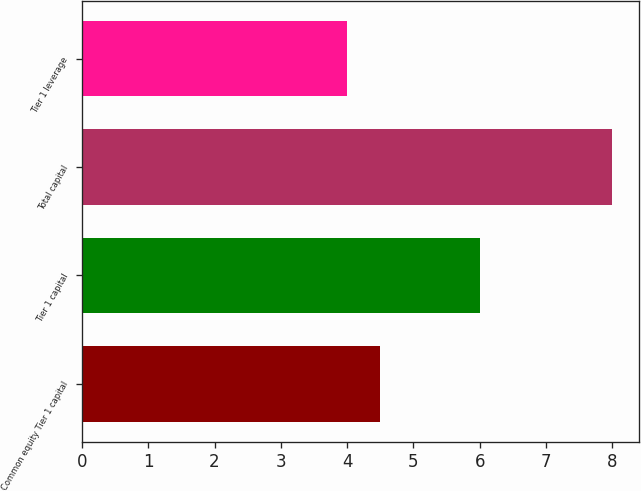Convert chart. <chart><loc_0><loc_0><loc_500><loc_500><bar_chart><fcel>Common equity Tier 1 capital<fcel>Tier 1 capital<fcel>Total capital<fcel>Tier 1 leverage<nl><fcel>4.5<fcel>6<fcel>8<fcel>4<nl></chart> 